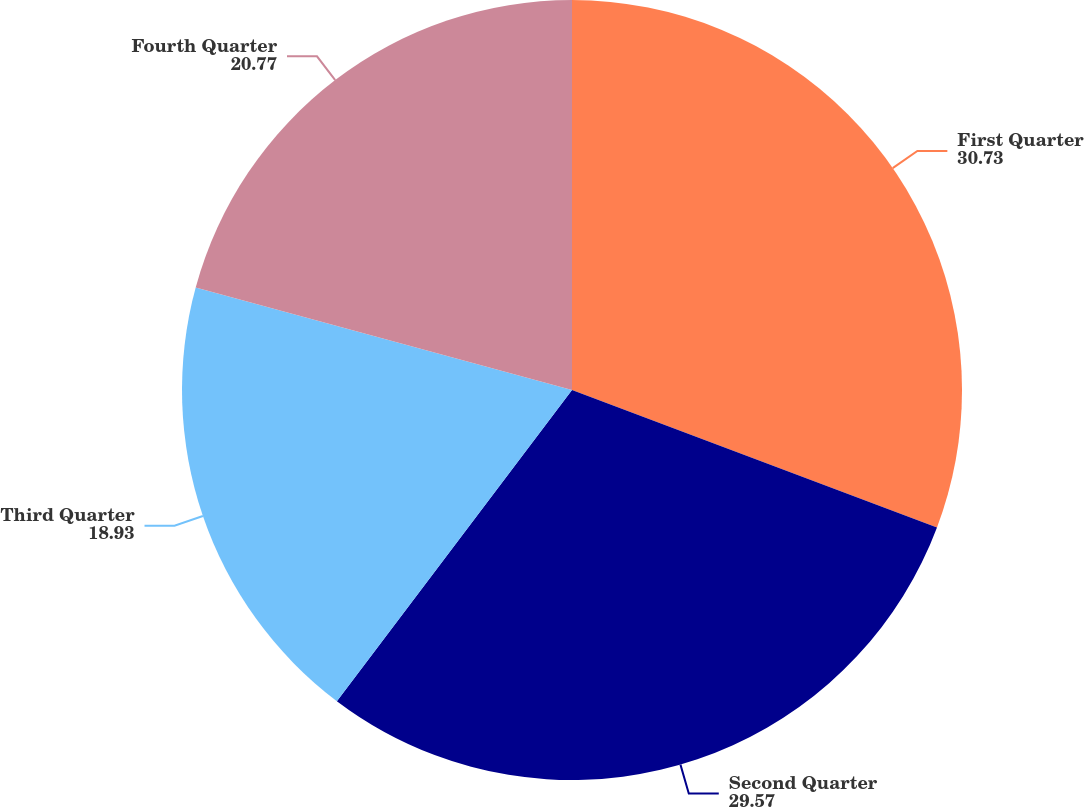Convert chart. <chart><loc_0><loc_0><loc_500><loc_500><pie_chart><fcel>First Quarter<fcel>Second Quarter<fcel>Third Quarter<fcel>Fourth Quarter<nl><fcel>30.73%<fcel>29.57%<fcel>18.93%<fcel>20.77%<nl></chart> 